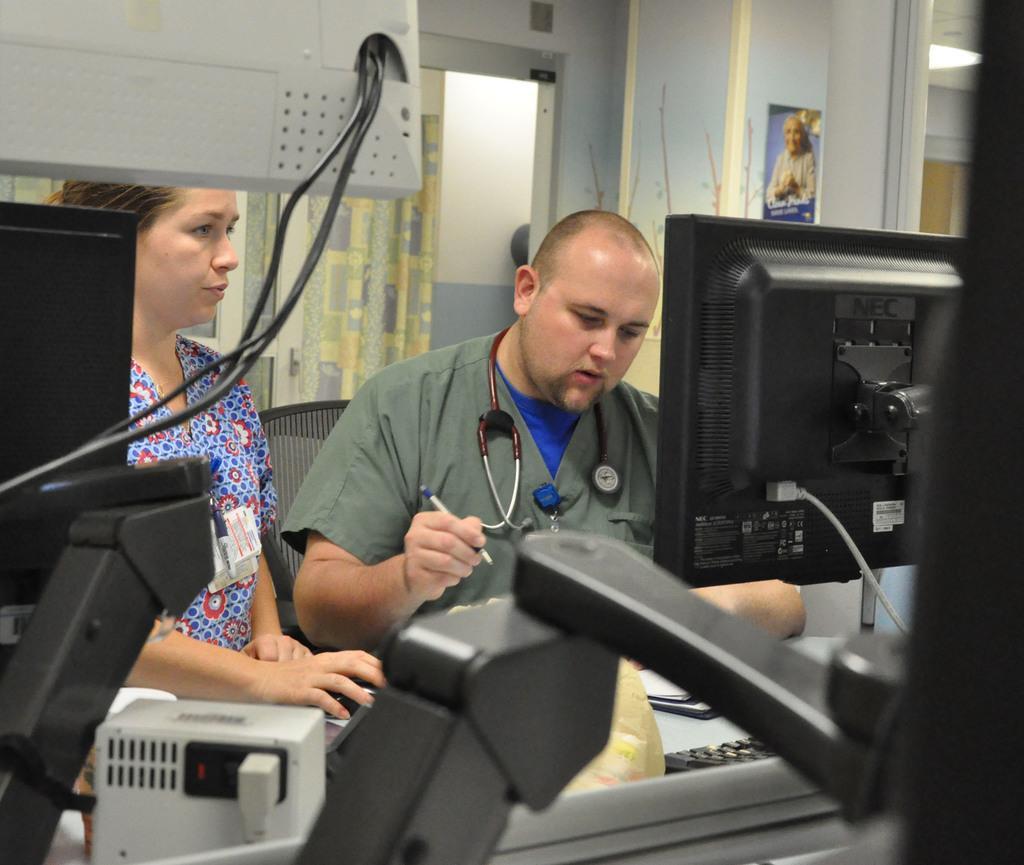Please provide a concise description of this image. In the picture we can see a man standing, he is with a stethoscope and holding a pen and beside him we can see a woman standing near the desk and on it we can see a monitor and some screen with wires to it and behind them we can see the wall with an exit and a curtain near it. 